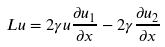Convert formula to latex. <formula><loc_0><loc_0><loc_500><loc_500>L u = 2 \gamma u \frac { \partial u _ { 1 } } { \partial x } - 2 \gamma \frac { \partial u _ { 2 } } { \partial x }</formula> 